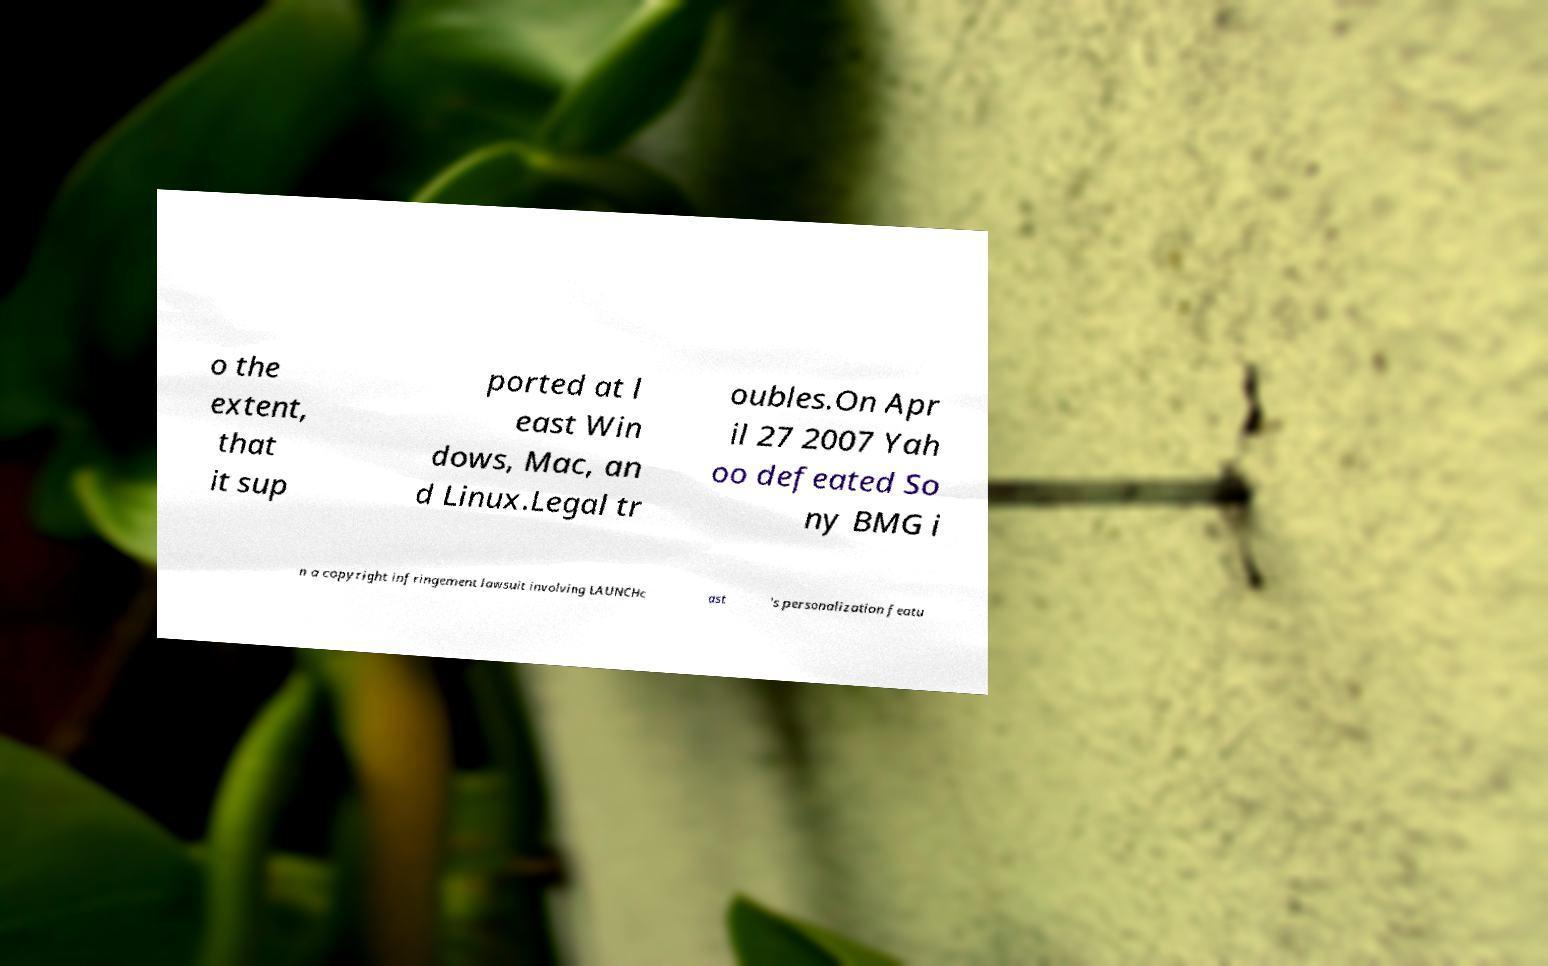For documentation purposes, I need the text within this image transcribed. Could you provide that? o the extent, that it sup ported at l east Win dows, Mac, an d Linux.Legal tr oubles.On Apr il 27 2007 Yah oo defeated So ny BMG i n a copyright infringement lawsuit involving LAUNCHc ast 's personalization featu 